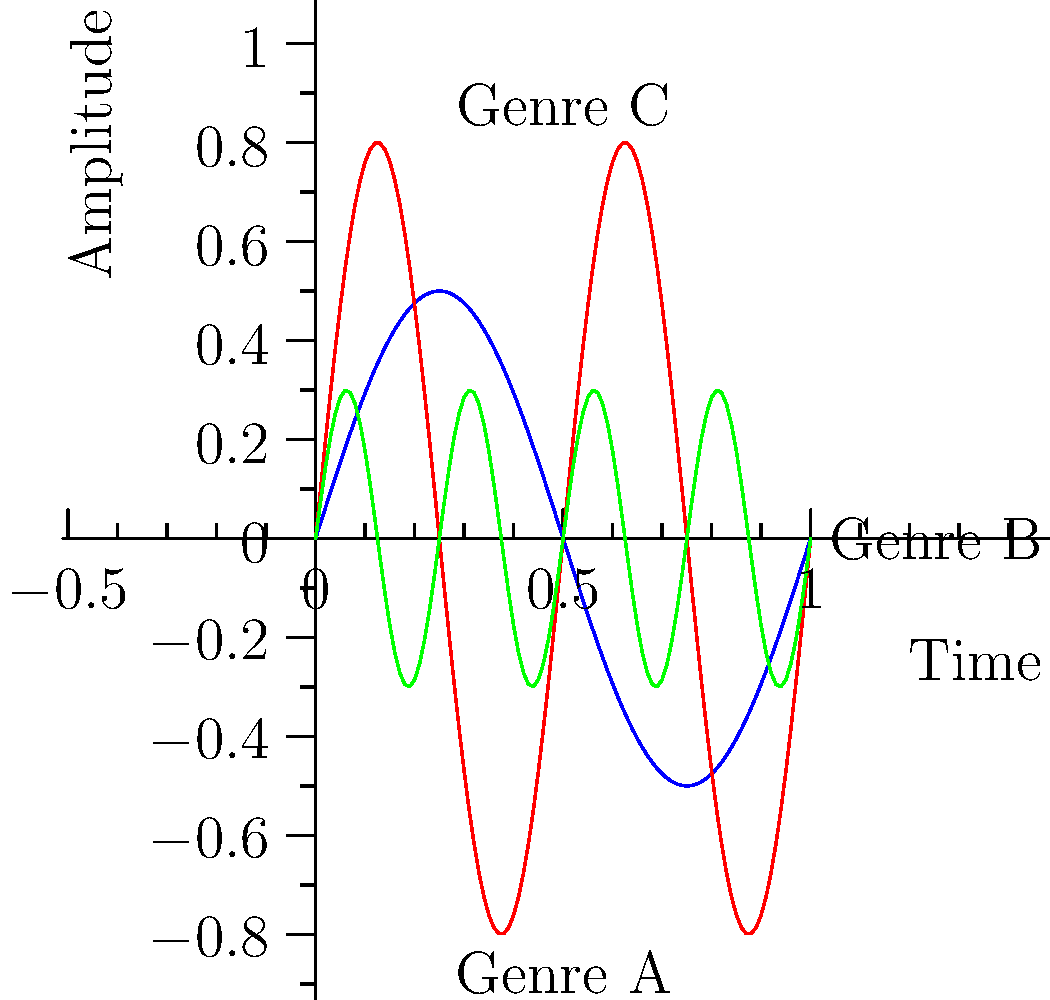As a versatile vocalist transitioning between genres, analyze the waveform patterns shown in the graph. Which genre is likely to have the highest tempo and most complex rhythmic structure? To answer this question, we need to analyze the waveform patterns for each genre:

1. Genre A (Blue):
   - Has the lowest frequency (fewest cycles per unit time)
   - Largest amplitude (highest peaks)
   - Represents a slower, more prominent beat

2. Genre B (Red):
   - Medium frequency (more cycles than A, fewer than C)
   - Medium amplitude
   - Represents a moderate tempo with balanced prominence

3. Genre C (Green):
   - Highest frequency (most cycles per unit time)
   - Smallest amplitude
   - Represents the fastest tempo and most complex rhythmic structure

The frequency of the waveform corresponds to the tempo of the music. Higher frequency means more cycles per unit time, which translates to a faster tempo.

The complexity of the waveform (more oscillations in the same time frame) indicates a more intricate rhythmic structure, as it represents more musical events occurring in the same time period.

Therefore, Genre C, with its highest frequency and most oscillations, is likely to have the highest tempo and most complex rhythmic structure.
Answer: Genre C 